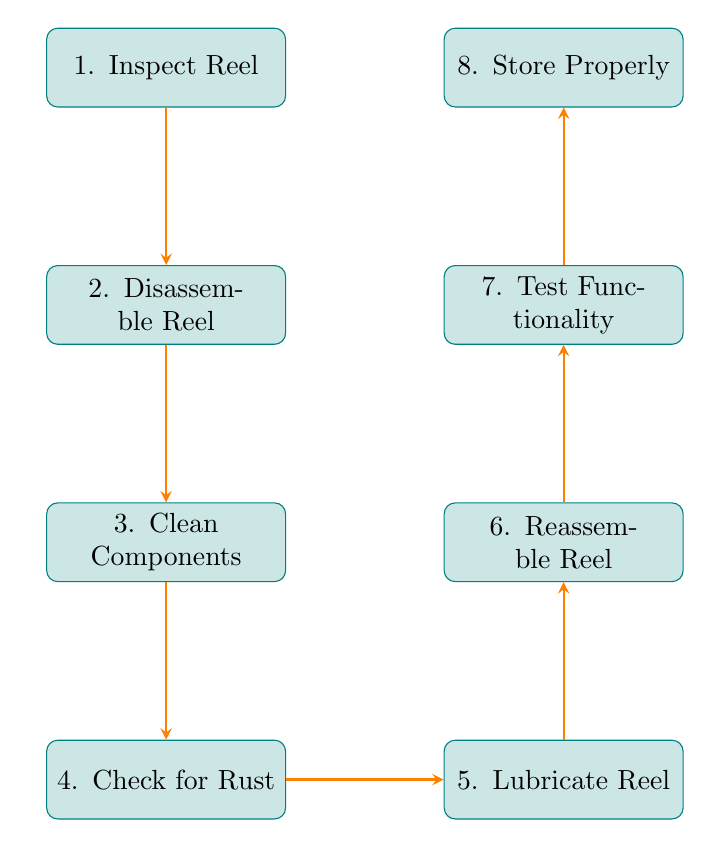What is the first step in the maintenance routine? According to the flow chart, the first step is "Inspect Reel." The nodes are arranged sequentially, and "Inspect Reel" is positioned at the top, indicating that it is the starting point of the process.
Answer: Inspect Reel How many nodes are present in the diagram? The diagram lists eight distinct steps, each represented by a node. Counting each node results in a total of eight.
Answer: Eight What is the last step in the process? The last node at the top of the flow chart is labeled "Store Properly," indicating that this is the final step of the maintenance routine.
Answer: Store Properly What do you do after checking for rust? After checking for rust, the next step indicated in the flow chart is to "Lubricate Reel," as shown by the directed arrow from the "Check for Rust" node to the "Lubricate Reel" node.
Answer: Lubricate Reel Which two steps are directly linked together after cleaning the components? From the diagram, after "Clean Components," the next step is "Check for Rust." Thus, these two steps are directly linked.
Answer: Check for Rust What action should be taken before reassembling the reel? According to the flow chart, after lubricating the reel, the next action is to "Reassemble Reel," which is a prerequisite for the reassembly process.
Answer: Lubricate Reel How many edges connect the nodes in the diagram? Each step or node in the flow chart connects sequentially, with one directed edge leading to the next. Since there are eight nodes, there are seven edges connecting them.
Answer: Seven What is the purpose of testing functionality? The "Test Functionality" step ensures that the reel works smoothly and makes no unusual noises. This is crucial for confirming that maintenance has been successful.
Answer: Ensure smooth operation 